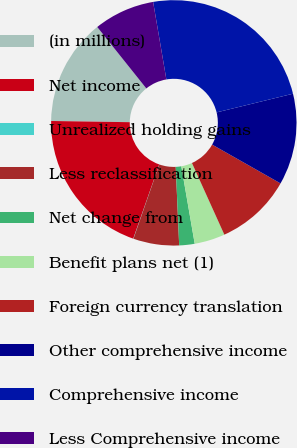<chart> <loc_0><loc_0><loc_500><loc_500><pie_chart><fcel>(in millions)<fcel>Net income<fcel>Unrealized holding gains<fcel>Less reclassification<fcel>Net change from<fcel>Benefit plans net (1)<fcel>Foreign currency translation<fcel>Other comprehensive income<fcel>Comprehensive income<fcel>Less Comprehensive income<nl><fcel>14.03%<fcel>19.88%<fcel>0.03%<fcel>6.03%<fcel>2.03%<fcel>4.03%<fcel>10.03%<fcel>12.03%<fcel>23.88%<fcel>8.03%<nl></chart> 